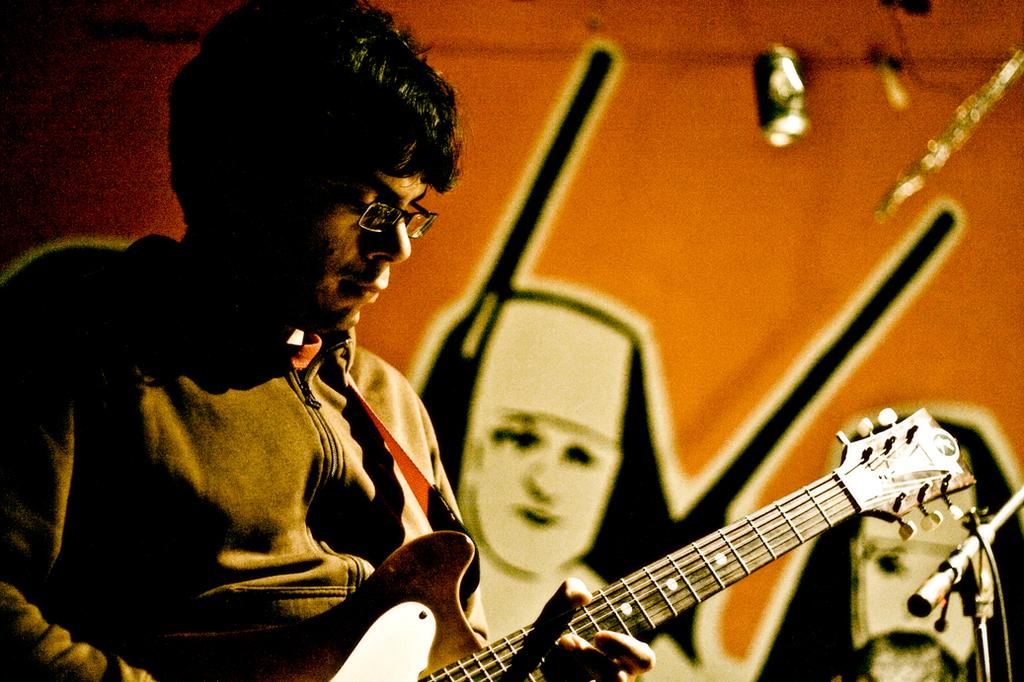What is the main subject of the image? There is a person in the image. What is the person holding in the image? The person is holding a guitar. What can be seen on the wall in the image? There is a scenery on the wall in the image. What type of fang can be seen in the person's mouth in the image? There is no fang visible in the person's mouth in the image. How many cattle are present in the image? There are no cattle present in the image. 